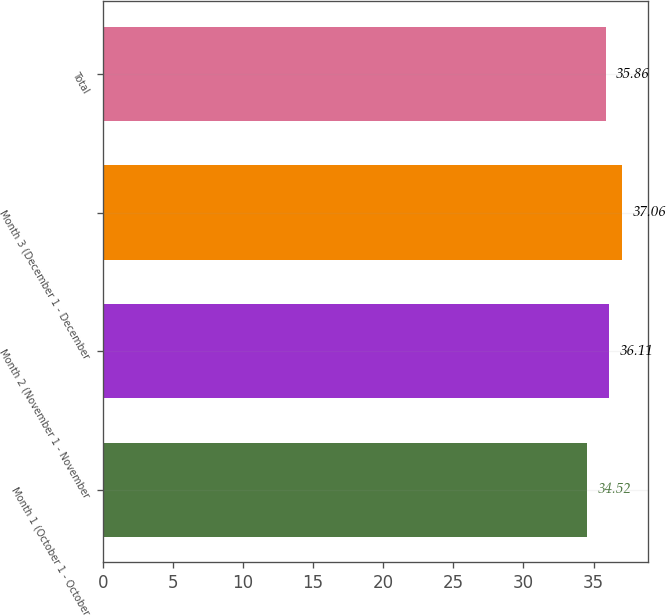Convert chart. <chart><loc_0><loc_0><loc_500><loc_500><bar_chart><fcel>Month 1 (October 1 - October<fcel>Month 2 (November 1 - November<fcel>Month 3 (December 1 - December<fcel>Total<nl><fcel>34.52<fcel>36.11<fcel>37.06<fcel>35.86<nl></chart> 